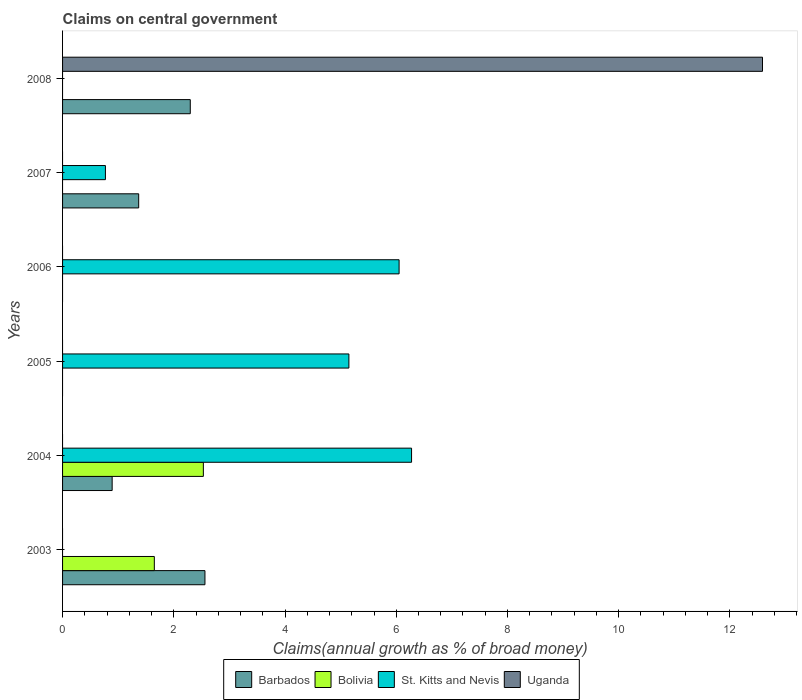How many different coloured bars are there?
Make the answer very short. 4. Are the number of bars on each tick of the Y-axis equal?
Your response must be concise. No. How many bars are there on the 1st tick from the top?
Offer a very short reply. 2. How many bars are there on the 1st tick from the bottom?
Your answer should be very brief. 2. In how many cases, is the number of bars for a given year not equal to the number of legend labels?
Keep it short and to the point. 6. Across all years, what is the maximum percentage of broad money claimed on centeral government in Bolivia?
Give a very brief answer. 2.53. Across all years, what is the minimum percentage of broad money claimed on centeral government in St. Kitts and Nevis?
Keep it short and to the point. 0. In which year was the percentage of broad money claimed on centeral government in Barbados maximum?
Your response must be concise. 2003. What is the total percentage of broad money claimed on centeral government in Uganda in the graph?
Provide a short and direct response. 12.59. What is the difference between the percentage of broad money claimed on centeral government in Uganda in 2004 and the percentage of broad money claimed on centeral government in Bolivia in 2003?
Your answer should be compact. -1.65. What is the average percentage of broad money claimed on centeral government in Barbados per year?
Keep it short and to the point. 1.19. In the year 2003, what is the difference between the percentage of broad money claimed on centeral government in Bolivia and percentage of broad money claimed on centeral government in Barbados?
Your answer should be very brief. -0.91. What is the ratio of the percentage of broad money claimed on centeral government in Barbados in 2003 to that in 2007?
Your answer should be very brief. 1.87. Is the percentage of broad money claimed on centeral government in St. Kitts and Nevis in 2006 less than that in 2007?
Ensure brevity in your answer.  No. What is the difference between the highest and the second highest percentage of broad money claimed on centeral government in St. Kitts and Nevis?
Keep it short and to the point. 0.22. What is the difference between the highest and the lowest percentage of broad money claimed on centeral government in Barbados?
Keep it short and to the point. 2.56. In how many years, is the percentage of broad money claimed on centeral government in Uganda greater than the average percentage of broad money claimed on centeral government in Uganda taken over all years?
Offer a very short reply. 1. Is it the case that in every year, the sum of the percentage of broad money claimed on centeral government in Barbados and percentage of broad money claimed on centeral government in St. Kitts and Nevis is greater than the sum of percentage of broad money claimed on centeral government in Uganda and percentage of broad money claimed on centeral government in Bolivia?
Give a very brief answer. No. Is it the case that in every year, the sum of the percentage of broad money claimed on centeral government in Bolivia and percentage of broad money claimed on centeral government in Uganda is greater than the percentage of broad money claimed on centeral government in Barbados?
Your response must be concise. No. How many bars are there?
Keep it short and to the point. 11. Are all the bars in the graph horizontal?
Make the answer very short. Yes. What is the difference between two consecutive major ticks on the X-axis?
Make the answer very short. 2. Are the values on the major ticks of X-axis written in scientific E-notation?
Ensure brevity in your answer.  No. Does the graph contain grids?
Make the answer very short. No. Where does the legend appear in the graph?
Offer a terse response. Bottom center. How are the legend labels stacked?
Offer a very short reply. Horizontal. What is the title of the graph?
Your answer should be very brief. Claims on central government. What is the label or title of the X-axis?
Provide a short and direct response. Claims(annual growth as % of broad money). What is the Claims(annual growth as % of broad money) in Barbados in 2003?
Keep it short and to the point. 2.56. What is the Claims(annual growth as % of broad money) in Bolivia in 2003?
Provide a short and direct response. 1.65. What is the Claims(annual growth as % of broad money) in St. Kitts and Nevis in 2003?
Your answer should be very brief. 0. What is the Claims(annual growth as % of broad money) of Barbados in 2004?
Your answer should be very brief. 0.89. What is the Claims(annual growth as % of broad money) in Bolivia in 2004?
Make the answer very short. 2.53. What is the Claims(annual growth as % of broad money) of St. Kitts and Nevis in 2004?
Offer a very short reply. 6.28. What is the Claims(annual growth as % of broad money) in Uganda in 2004?
Make the answer very short. 0. What is the Claims(annual growth as % of broad money) of Barbados in 2005?
Offer a terse response. 0. What is the Claims(annual growth as % of broad money) in St. Kitts and Nevis in 2005?
Make the answer very short. 5.15. What is the Claims(annual growth as % of broad money) of Barbados in 2006?
Your answer should be very brief. 0. What is the Claims(annual growth as % of broad money) of Bolivia in 2006?
Provide a short and direct response. 0. What is the Claims(annual growth as % of broad money) in St. Kitts and Nevis in 2006?
Keep it short and to the point. 6.05. What is the Claims(annual growth as % of broad money) of Uganda in 2006?
Give a very brief answer. 0. What is the Claims(annual growth as % of broad money) of Barbados in 2007?
Your answer should be compact. 1.37. What is the Claims(annual growth as % of broad money) in St. Kitts and Nevis in 2007?
Provide a short and direct response. 0.77. What is the Claims(annual growth as % of broad money) in Barbados in 2008?
Your answer should be compact. 2.3. What is the Claims(annual growth as % of broad money) of St. Kitts and Nevis in 2008?
Offer a terse response. 0. What is the Claims(annual growth as % of broad money) of Uganda in 2008?
Your answer should be very brief. 12.59. Across all years, what is the maximum Claims(annual growth as % of broad money) of Barbados?
Provide a succinct answer. 2.56. Across all years, what is the maximum Claims(annual growth as % of broad money) in Bolivia?
Offer a terse response. 2.53. Across all years, what is the maximum Claims(annual growth as % of broad money) in St. Kitts and Nevis?
Give a very brief answer. 6.28. Across all years, what is the maximum Claims(annual growth as % of broad money) in Uganda?
Offer a terse response. 12.59. Across all years, what is the minimum Claims(annual growth as % of broad money) in Barbados?
Give a very brief answer. 0. Across all years, what is the minimum Claims(annual growth as % of broad money) in St. Kitts and Nevis?
Provide a short and direct response. 0. What is the total Claims(annual growth as % of broad money) of Barbados in the graph?
Your answer should be very brief. 7.12. What is the total Claims(annual growth as % of broad money) in Bolivia in the graph?
Offer a terse response. 4.18. What is the total Claims(annual growth as % of broad money) of St. Kitts and Nevis in the graph?
Provide a succinct answer. 18.25. What is the total Claims(annual growth as % of broad money) in Uganda in the graph?
Provide a short and direct response. 12.59. What is the difference between the Claims(annual growth as % of broad money) in Barbados in 2003 and that in 2004?
Offer a very short reply. 1.67. What is the difference between the Claims(annual growth as % of broad money) in Bolivia in 2003 and that in 2004?
Ensure brevity in your answer.  -0.88. What is the difference between the Claims(annual growth as % of broad money) of Barbados in 2003 and that in 2007?
Offer a terse response. 1.19. What is the difference between the Claims(annual growth as % of broad money) in Barbados in 2003 and that in 2008?
Provide a short and direct response. 0.26. What is the difference between the Claims(annual growth as % of broad money) in St. Kitts and Nevis in 2004 and that in 2005?
Offer a terse response. 1.13. What is the difference between the Claims(annual growth as % of broad money) of St. Kitts and Nevis in 2004 and that in 2006?
Provide a short and direct response. 0.22. What is the difference between the Claims(annual growth as % of broad money) of Barbados in 2004 and that in 2007?
Provide a succinct answer. -0.48. What is the difference between the Claims(annual growth as % of broad money) in St. Kitts and Nevis in 2004 and that in 2007?
Offer a terse response. 5.5. What is the difference between the Claims(annual growth as % of broad money) of Barbados in 2004 and that in 2008?
Give a very brief answer. -1.4. What is the difference between the Claims(annual growth as % of broad money) in St. Kitts and Nevis in 2005 and that in 2006?
Provide a succinct answer. -0.9. What is the difference between the Claims(annual growth as % of broad money) of St. Kitts and Nevis in 2005 and that in 2007?
Provide a short and direct response. 4.38. What is the difference between the Claims(annual growth as % of broad money) in St. Kitts and Nevis in 2006 and that in 2007?
Provide a short and direct response. 5.28. What is the difference between the Claims(annual growth as % of broad money) in Barbados in 2007 and that in 2008?
Your answer should be very brief. -0.93. What is the difference between the Claims(annual growth as % of broad money) of Barbados in 2003 and the Claims(annual growth as % of broad money) of Bolivia in 2004?
Offer a terse response. 0.03. What is the difference between the Claims(annual growth as % of broad money) in Barbados in 2003 and the Claims(annual growth as % of broad money) in St. Kitts and Nevis in 2004?
Offer a terse response. -3.71. What is the difference between the Claims(annual growth as % of broad money) of Bolivia in 2003 and the Claims(annual growth as % of broad money) of St. Kitts and Nevis in 2004?
Your answer should be very brief. -4.63. What is the difference between the Claims(annual growth as % of broad money) in Barbados in 2003 and the Claims(annual growth as % of broad money) in St. Kitts and Nevis in 2005?
Offer a terse response. -2.59. What is the difference between the Claims(annual growth as % of broad money) in Bolivia in 2003 and the Claims(annual growth as % of broad money) in St. Kitts and Nevis in 2005?
Offer a terse response. -3.5. What is the difference between the Claims(annual growth as % of broad money) in Barbados in 2003 and the Claims(annual growth as % of broad money) in St. Kitts and Nevis in 2006?
Offer a very short reply. -3.49. What is the difference between the Claims(annual growth as % of broad money) of Bolivia in 2003 and the Claims(annual growth as % of broad money) of St. Kitts and Nevis in 2006?
Offer a very short reply. -4.4. What is the difference between the Claims(annual growth as % of broad money) in Barbados in 2003 and the Claims(annual growth as % of broad money) in St. Kitts and Nevis in 2007?
Provide a short and direct response. 1.79. What is the difference between the Claims(annual growth as % of broad money) in Bolivia in 2003 and the Claims(annual growth as % of broad money) in St. Kitts and Nevis in 2007?
Your answer should be very brief. 0.88. What is the difference between the Claims(annual growth as % of broad money) in Barbados in 2003 and the Claims(annual growth as % of broad money) in Uganda in 2008?
Make the answer very short. -10.03. What is the difference between the Claims(annual growth as % of broad money) of Bolivia in 2003 and the Claims(annual growth as % of broad money) of Uganda in 2008?
Offer a terse response. -10.94. What is the difference between the Claims(annual growth as % of broad money) of Barbados in 2004 and the Claims(annual growth as % of broad money) of St. Kitts and Nevis in 2005?
Provide a short and direct response. -4.26. What is the difference between the Claims(annual growth as % of broad money) in Bolivia in 2004 and the Claims(annual growth as % of broad money) in St. Kitts and Nevis in 2005?
Your answer should be compact. -2.62. What is the difference between the Claims(annual growth as % of broad money) of Barbados in 2004 and the Claims(annual growth as % of broad money) of St. Kitts and Nevis in 2006?
Your answer should be compact. -5.16. What is the difference between the Claims(annual growth as % of broad money) in Bolivia in 2004 and the Claims(annual growth as % of broad money) in St. Kitts and Nevis in 2006?
Provide a short and direct response. -3.52. What is the difference between the Claims(annual growth as % of broad money) of Barbados in 2004 and the Claims(annual growth as % of broad money) of St. Kitts and Nevis in 2007?
Make the answer very short. 0.12. What is the difference between the Claims(annual growth as % of broad money) in Bolivia in 2004 and the Claims(annual growth as % of broad money) in St. Kitts and Nevis in 2007?
Your response must be concise. 1.76. What is the difference between the Claims(annual growth as % of broad money) in Barbados in 2004 and the Claims(annual growth as % of broad money) in Uganda in 2008?
Give a very brief answer. -11.69. What is the difference between the Claims(annual growth as % of broad money) in Bolivia in 2004 and the Claims(annual growth as % of broad money) in Uganda in 2008?
Your answer should be very brief. -10.05. What is the difference between the Claims(annual growth as % of broad money) of St. Kitts and Nevis in 2004 and the Claims(annual growth as % of broad money) of Uganda in 2008?
Your answer should be very brief. -6.31. What is the difference between the Claims(annual growth as % of broad money) in St. Kitts and Nevis in 2005 and the Claims(annual growth as % of broad money) in Uganda in 2008?
Provide a short and direct response. -7.44. What is the difference between the Claims(annual growth as % of broad money) in St. Kitts and Nevis in 2006 and the Claims(annual growth as % of broad money) in Uganda in 2008?
Make the answer very short. -6.53. What is the difference between the Claims(annual growth as % of broad money) of Barbados in 2007 and the Claims(annual growth as % of broad money) of Uganda in 2008?
Provide a succinct answer. -11.22. What is the difference between the Claims(annual growth as % of broad money) in St. Kitts and Nevis in 2007 and the Claims(annual growth as % of broad money) in Uganda in 2008?
Provide a succinct answer. -11.81. What is the average Claims(annual growth as % of broad money) of Barbados per year?
Keep it short and to the point. 1.19. What is the average Claims(annual growth as % of broad money) of Bolivia per year?
Provide a short and direct response. 0.7. What is the average Claims(annual growth as % of broad money) in St. Kitts and Nevis per year?
Your answer should be compact. 3.04. What is the average Claims(annual growth as % of broad money) in Uganda per year?
Give a very brief answer. 2.1. In the year 2003, what is the difference between the Claims(annual growth as % of broad money) in Barbados and Claims(annual growth as % of broad money) in Bolivia?
Your answer should be very brief. 0.91. In the year 2004, what is the difference between the Claims(annual growth as % of broad money) of Barbados and Claims(annual growth as % of broad money) of Bolivia?
Provide a short and direct response. -1.64. In the year 2004, what is the difference between the Claims(annual growth as % of broad money) of Barbados and Claims(annual growth as % of broad money) of St. Kitts and Nevis?
Offer a very short reply. -5.38. In the year 2004, what is the difference between the Claims(annual growth as % of broad money) of Bolivia and Claims(annual growth as % of broad money) of St. Kitts and Nevis?
Offer a terse response. -3.74. In the year 2007, what is the difference between the Claims(annual growth as % of broad money) of Barbados and Claims(annual growth as % of broad money) of St. Kitts and Nevis?
Give a very brief answer. 0.6. In the year 2008, what is the difference between the Claims(annual growth as % of broad money) in Barbados and Claims(annual growth as % of broad money) in Uganda?
Your response must be concise. -10.29. What is the ratio of the Claims(annual growth as % of broad money) of Barbados in 2003 to that in 2004?
Your answer should be very brief. 2.87. What is the ratio of the Claims(annual growth as % of broad money) of Bolivia in 2003 to that in 2004?
Make the answer very short. 0.65. What is the ratio of the Claims(annual growth as % of broad money) of Barbados in 2003 to that in 2007?
Keep it short and to the point. 1.87. What is the ratio of the Claims(annual growth as % of broad money) of Barbados in 2003 to that in 2008?
Your response must be concise. 1.11. What is the ratio of the Claims(annual growth as % of broad money) of St. Kitts and Nevis in 2004 to that in 2005?
Offer a terse response. 1.22. What is the ratio of the Claims(annual growth as % of broad money) of St. Kitts and Nevis in 2004 to that in 2006?
Keep it short and to the point. 1.04. What is the ratio of the Claims(annual growth as % of broad money) in Barbados in 2004 to that in 2007?
Give a very brief answer. 0.65. What is the ratio of the Claims(annual growth as % of broad money) in St. Kitts and Nevis in 2004 to that in 2007?
Provide a succinct answer. 8.14. What is the ratio of the Claims(annual growth as % of broad money) of Barbados in 2004 to that in 2008?
Your response must be concise. 0.39. What is the ratio of the Claims(annual growth as % of broad money) of St. Kitts and Nevis in 2005 to that in 2006?
Offer a very short reply. 0.85. What is the ratio of the Claims(annual growth as % of broad money) in St. Kitts and Nevis in 2005 to that in 2007?
Ensure brevity in your answer.  6.68. What is the ratio of the Claims(annual growth as % of broad money) of St. Kitts and Nevis in 2006 to that in 2007?
Make the answer very short. 7.85. What is the ratio of the Claims(annual growth as % of broad money) in Barbados in 2007 to that in 2008?
Give a very brief answer. 0.6. What is the difference between the highest and the second highest Claims(annual growth as % of broad money) of Barbados?
Give a very brief answer. 0.26. What is the difference between the highest and the second highest Claims(annual growth as % of broad money) in St. Kitts and Nevis?
Your answer should be compact. 0.22. What is the difference between the highest and the lowest Claims(annual growth as % of broad money) in Barbados?
Your answer should be compact. 2.56. What is the difference between the highest and the lowest Claims(annual growth as % of broad money) in Bolivia?
Keep it short and to the point. 2.53. What is the difference between the highest and the lowest Claims(annual growth as % of broad money) of St. Kitts and Nevis?
Your answer should be very brief. 6.28. What is the difference between the highest and the lowest Claims(annual growth as % of broad money) of Uganda?
Provide a short and direct response. 12.59. 